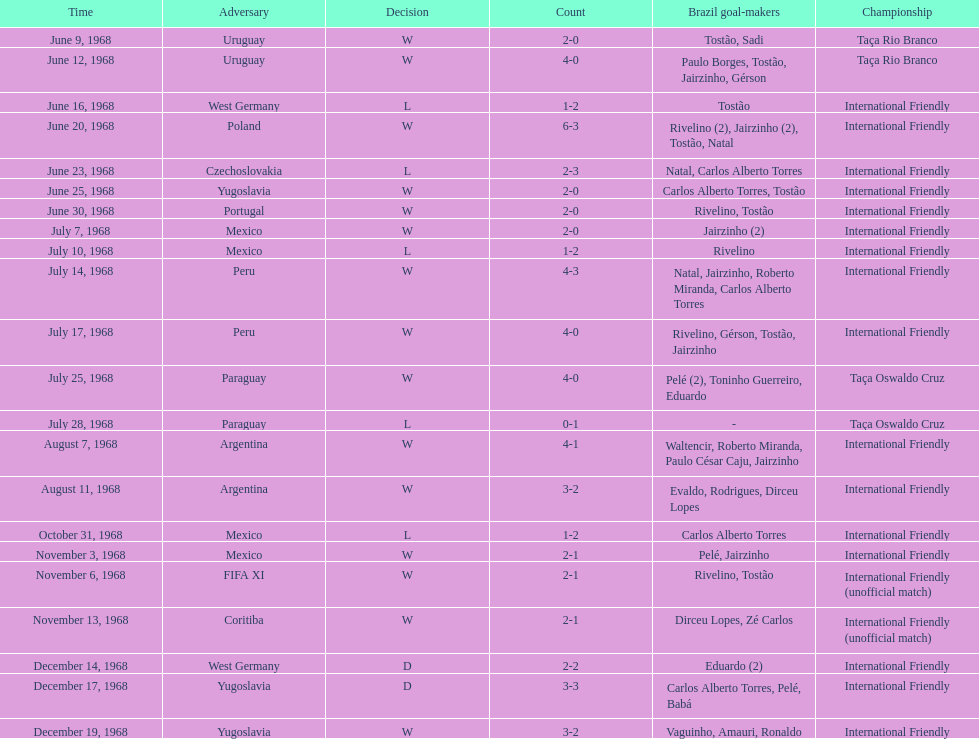What's the total number of ties? 2. 